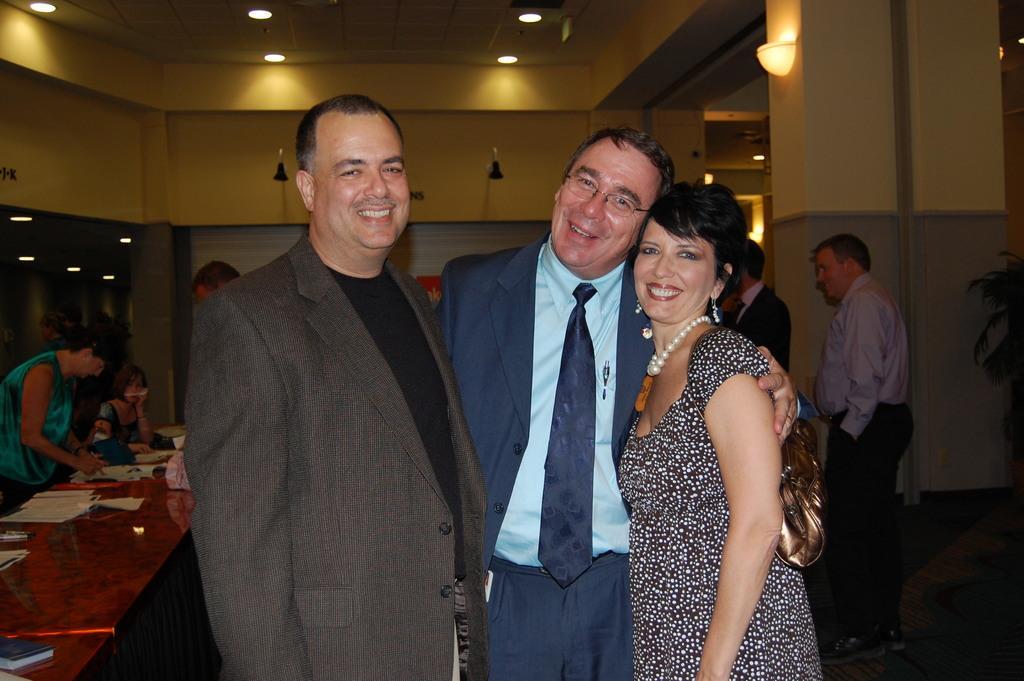Could you give a brief overview of what you see in this image? This picture shows couple of men and woman and we see few people standing on the side and we see papers on the table and a woman seated. We see a man holding a woman with his hand and woman wore a handbag and a ornament and we see lights on the roof and a plant on the side. 